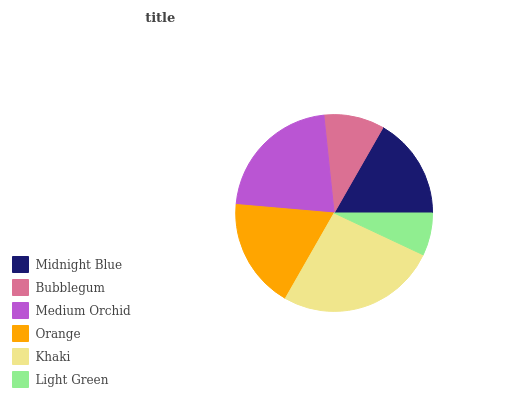Is Light Green the minimum?
Answer yes or no. Yes. Is Khaki the maximum?
Answer yes or no. Yes. Is Bubblegum the minimum?
Answer yes or no. No. Is Bubblegum the maximum?
Answer yes or no. No. Is Midnight Blue greater than Bubblegum?
Answer yes or no. Yes. Is Bubblegum less than Midnight Blue?
Answer yes or no. Yes. Is Bubblegum greater than Midnight Blue?
Answer yes or no. No. Is Midnight Blue less than Bubblegum?
Answer yes or no. No. Is Orange the high median?
Answer yes or no. Yes. Is Midnight Blue the low median?
Answer yes or no. Yes. Is Light Green the high median?
Answer yes or no. No. Is Bubblegum the low median?
Answer yes or no. No. 